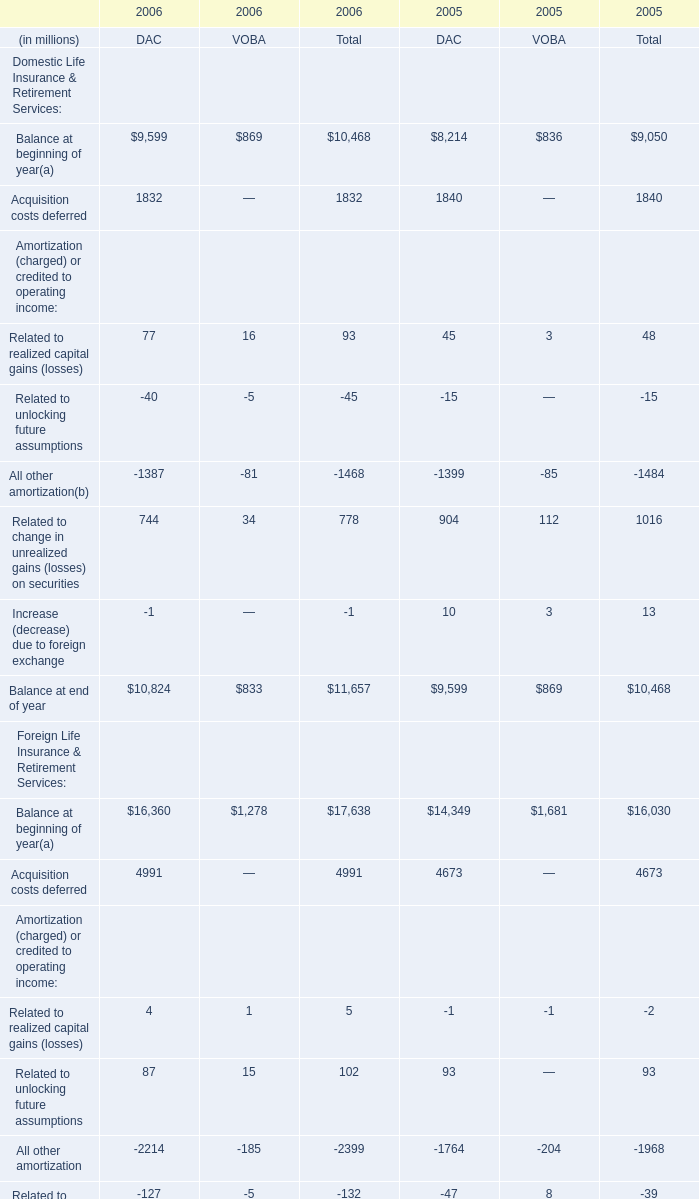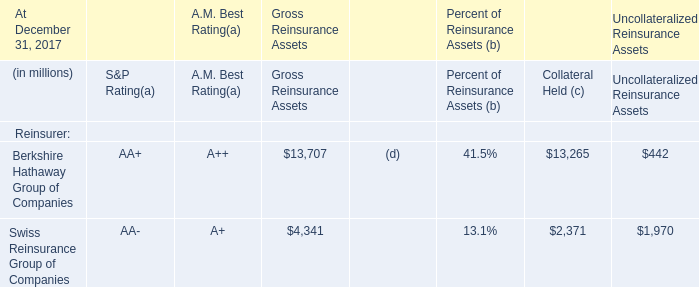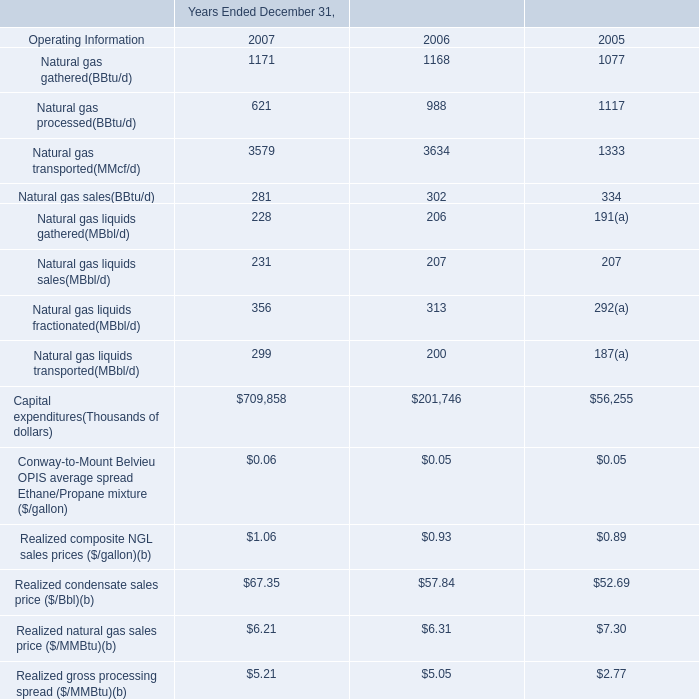What's the sum of Domestic Life Insurance & Retirement Services in 2006? (in million) 
Computations: (10468 + 1832)
Answer: 12300.0. 